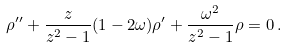Convert formula to latex. <formula><loc_0><loc_0><loc_500><loc_500>\rho ^ { \prime \prime } + \frac { z } { z ^ { 2 } - 1 } ( 1 - 2 \omega ) \rho ^ { \prime } + \frac { \omega ^ { 2 } } { z ^ { 2 } - 1 } \rho = 0 \, .</formula> 